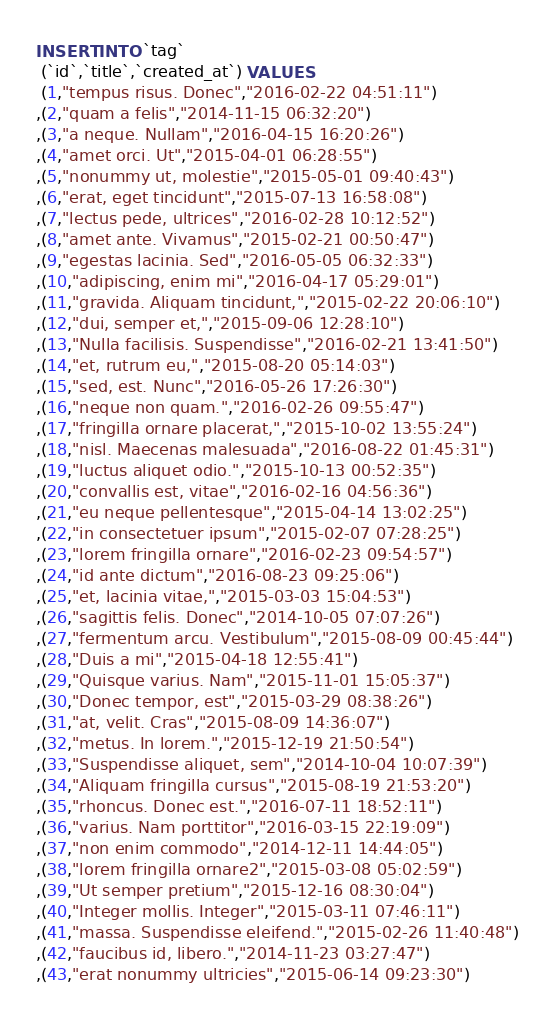Convert code to text. <code><loc_0><loc_0><loc_500><loc_500><_SQL_>INSERT INTO `tag`
 (`id`,`title`,`created_at`) VALUES
 (1,"tempus risus. Donec","2016-02-22 04:51:11")
,(2,"quam a felis","2014-11-15 06:32:20")
,(3,"a neque. Nullam","2016-04-15 16:20:26")
,(4,"amet orci. Ut","2015-04-01 06:28:55")
,(5,"nonummy ut, molestie","2015-05-01 09:40:43")
,(6,"erat, eget tincidunt","2015-07-13 16:58:08")
,(7,"lectus pede, ultrices","2016-02-28 10:12:52")
,(8,"amet ante. Vivamus","2015-02-21 00:50:47")
,(9,"egestas lacinia. Sed","2016-05-05 06:32:33")
,(10,"adipiscing, enim mi","2016-04-17 05:29:01")
,(11,"gravida. Aliquam tincidunt,","2015-02-22 20:06:10")
,(12,"dui, semper et,","2015-09-06 12:28:10")
,(13,"Nulla facilisis. Suspendisse","2016-02-21 13:41:50")
,(14,"et, rutrum eu,","2015-08-20 05:14:03")
,(15,"sed, est. Nunc","2016-05-26 17:26:30")
,(16,"neque non quam.","2016-02-26 09:55:47")
,(17,"fringilla ornare placerat,","2015-10-02 13:55:24")
,(18,"nisl. Maecenas malesuada","2016-08-22 01:45:31")
,(19,"luctus aliquet odio.","2015-10-13 00:52:35")
,(20,"convallis est, vitae","2016-02-16 04:56:36")
,(21,"eu neque pellentesque","2015-04-14 13:02:25")
,(22,"in consectetuer ipsum","2015-02-07 07:28:25")
,(23,"lorem fringilla ornare","2016-02-23 09:54:57")
,(24,"id ante dictum","2016-08-23 09:25:06")
,(25,"et, lacinia vitae,","2015-03-03 15:04:53")
,(26,"sagittis felis. Donec","2014-10-05 07:07:26")
,(27,"fermentum arcu. Vestibulum","2015-08-09 00:45:44")
,(28,"Duis a mi","2015-04-18 12:55:41")
,(29,"Quisque varius. Nam","2015-11-01 15:05:37")
,(30,"Donec tempor, est","2015-03-29 08:38:26")
,(31,"at, velit. Cras","2015-08-09 14:36:07")
,(32,"metus. In lorem.","2015-12-19 21:50:54")
,(33,"Suspendisse aliquet, sem","2014-10-04 10:07:39")
,(34,"Aliquam fringilla cursus","2015-08-19 21:53:20")
,(35,"rhoncus. Donec est.","2016-07-11 18:52:11")
,(36,"varius. Nam porttitor","2016-03-15 22:19:09")
,(37,"non enim commodo","2014-12-11 14:44:05")
,(38,"lorem fringilla ornare2","2015-03-08 05:02:59")
,(39,"Ut semper pretium","2015-12-16 08:30:04")
,(40,"Integer mollis. Integer","2015-03-11 07:46:11")
,(41,"massa. Suspendisse eleifend.","2015-02-26 11:40:48")
,(42,"faucibus id, libero.","2014-11-23 03:27:47")
,(43,"erat nonummy ultricies","2015-06-14 09:23:30")</code> 